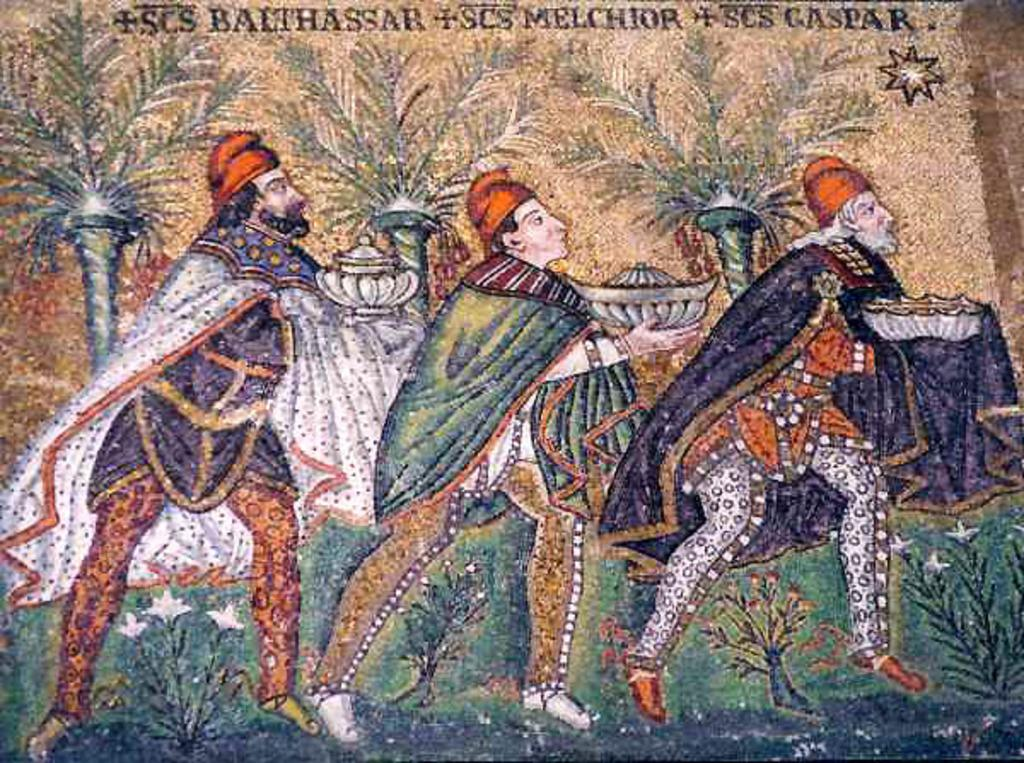How many people are in the image? There are three persons in the image. What are the persons doing in the image? The persons are standing and holding an object in their hands. What type of vegetation can be seen in the image? There are plants and trees in the image. What is written above the persons in the image? There is text written above the persons in the image. What type of square can be seen in the image? There is no square present in the image. What thrill can be experienced by the persons in the image? The image does not provide information about any thrilling experiences the persons might be having. 